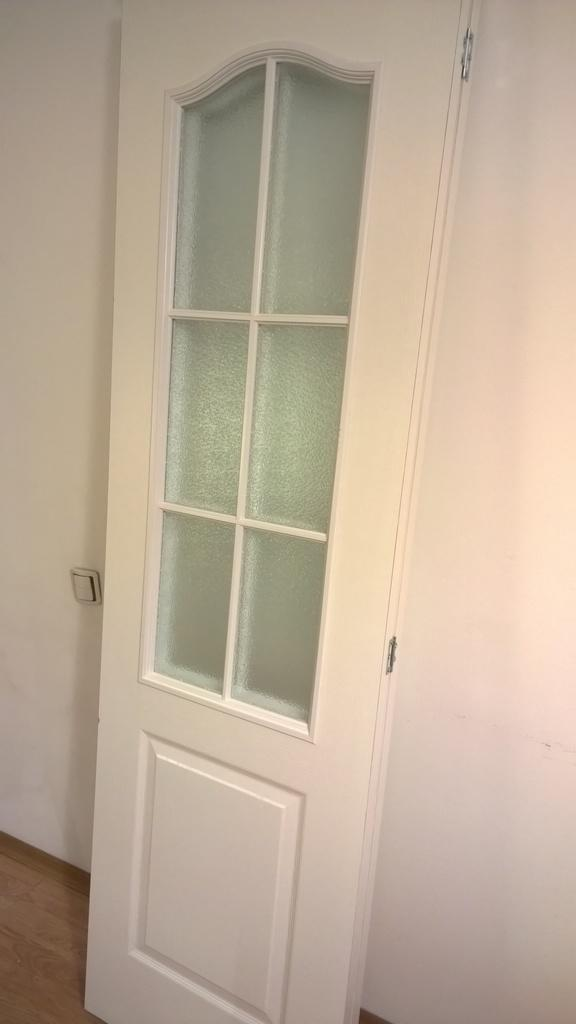What is the main object in the image? There is a door in the image. What feature is attached to the door? There is a glass mirror attached to the door. Can you tell me how many dogs are teaching celery in the image? There are no dogs or celery present in the image; it only features a door with a glass mirror attached to it. 